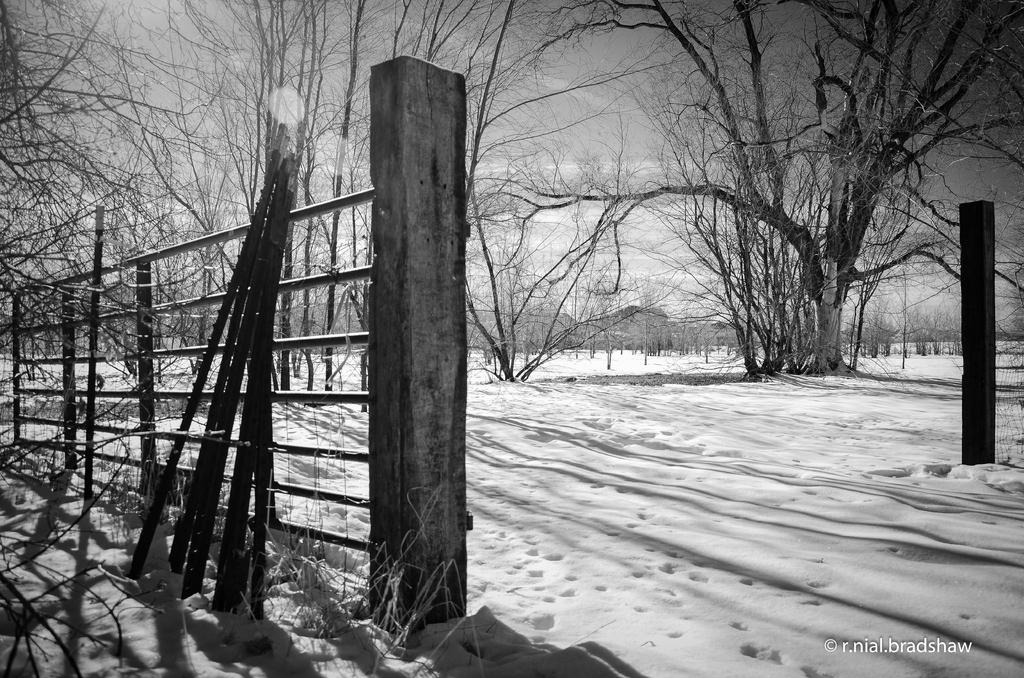What type of vegetation is present in the image? There are many trees in the image. What is the weather condition in the image? There is snow visible in the image, indicating a cold and likely wintery condition. What can be seen above the trees in the image? The sky is visible in the image. What architectural feature is present on the left side of the image? There is a fence at the left side of the image. What type of shirt is the letter wearing in the image? There is no shirt or letter present in the image; it features trees, snow, sky, and a fence. 